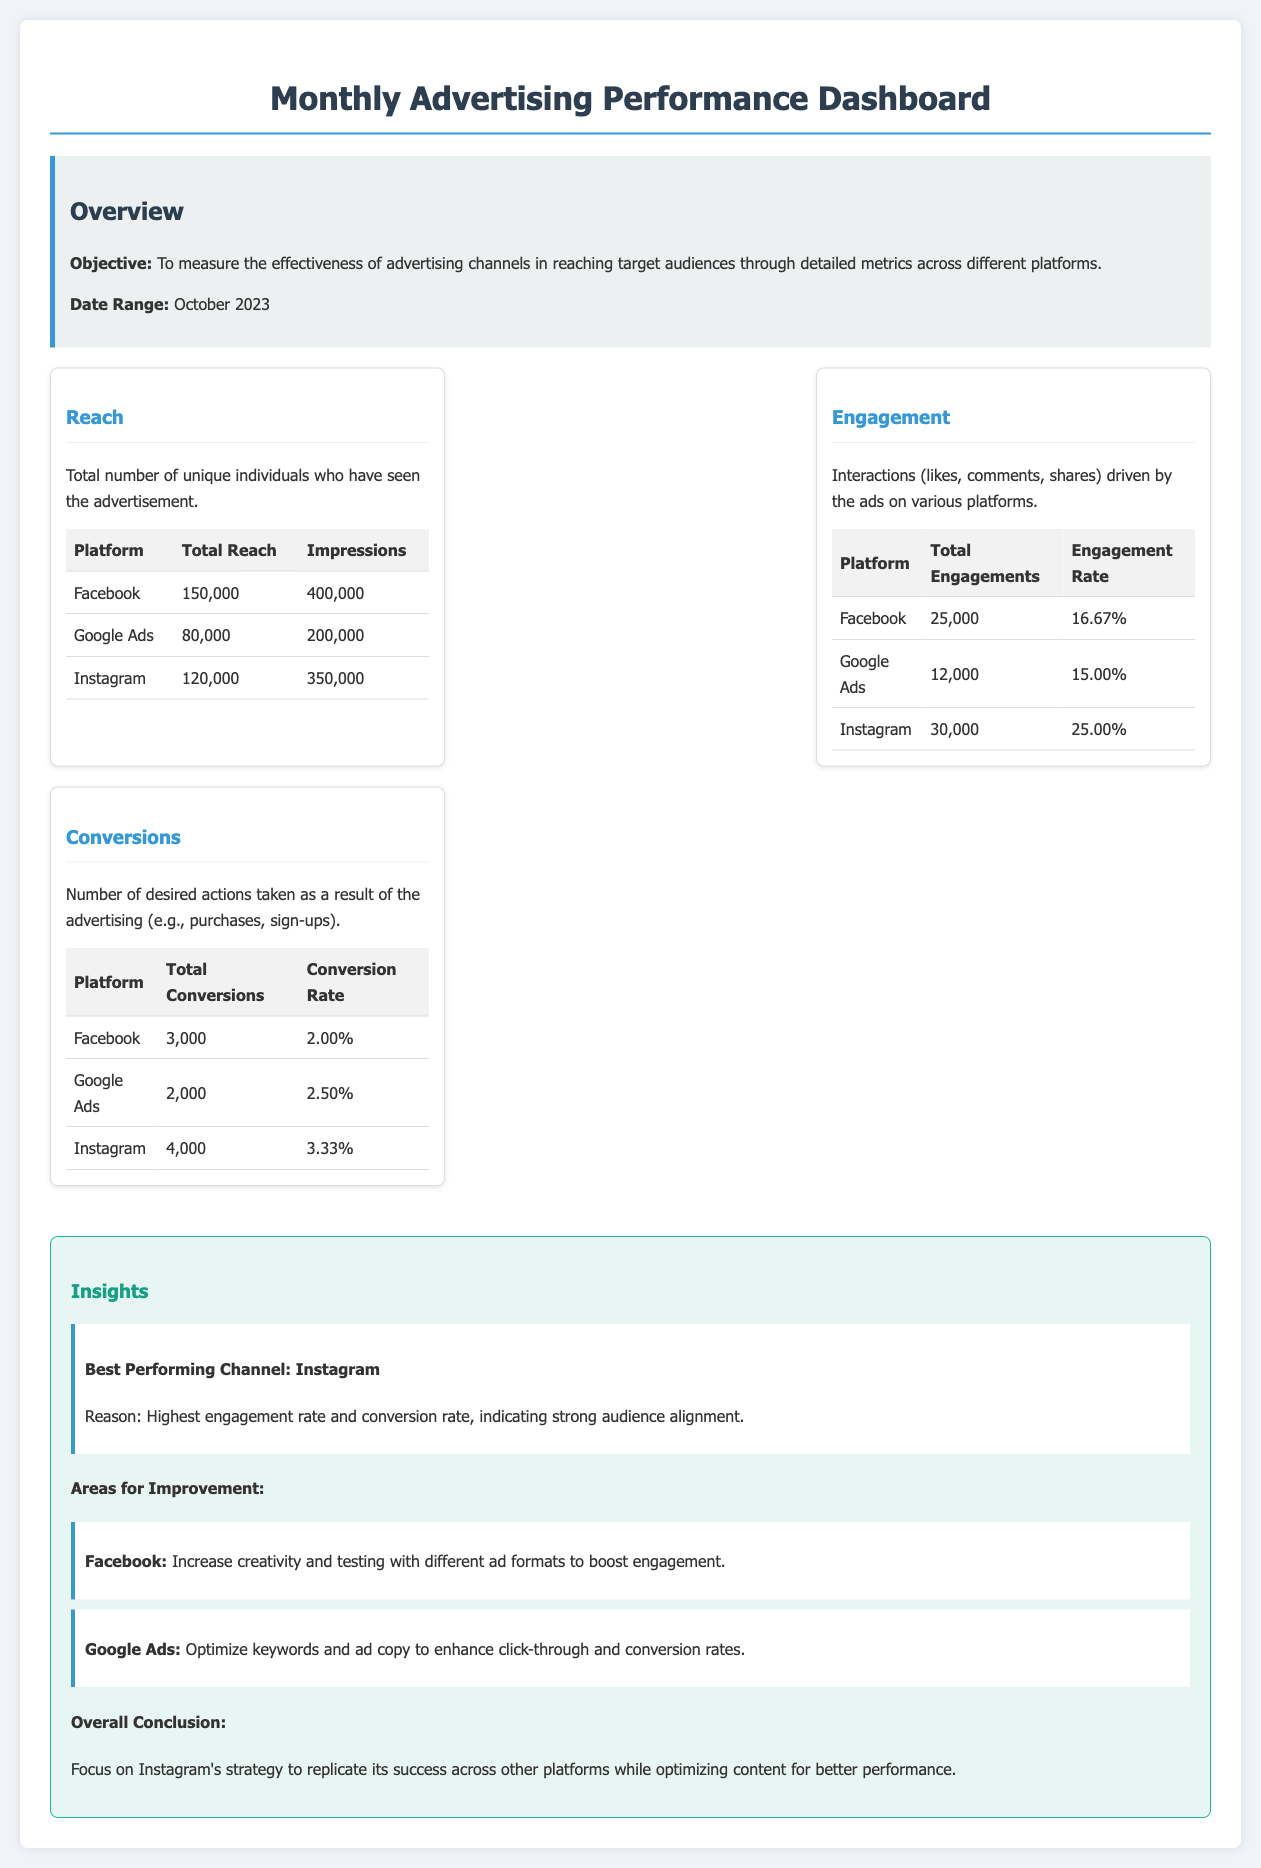What is the total reach on Facebook? The total reach on Facebook is specified in the reach metrics table, which shows 150,000 for Facebook.
Answer: 150,000 What is the engagement rate on Instagram? The engagement rate on Instagram is listed in the engagement metrics table as 25.00%.
Answer: 25.00% How many total conversions were achieved on Google Ads? The total conversions for Google Ads are indicated in the conversions table, which states 2,000.
Answer: 2,000 Which platform had the highest total engagements? The platform with the highest total engagements is mentioned in the engagement metrics table, showing 30,000 for Instagram.
Answer: Instagram What is the conclusion regarding the advertising strategy? The overall conclusion highlighted in the insights section states to focus on Instagram's strategy to replicate its success across other platforms.
Answer: Focus on Instagram's strategy What is the primary area for improvement on Facebook? The insights section mentions the primary area for improvement for Facebook is to increase creativity and testing with different ad formats to boost engagement.
Answer: Increase creativity and testing Which platform is identified as the best performing channel? The insights section explicitly identifies Instagram as the best performing channel.
Answer: Instagram What is the date range for the advertising performance metrics? The date range is stated in the overview section as October 2023.
Answer: October 2023 What is the total number of impressions for Google Ads? The total number of impressions for Google Ads can be found in the reach metrics table, which shows 200,000.
Answer: 200,000 